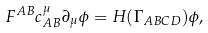Convert formula to latex. <formula><loc_0><loc_0><loc_500><loc_500>F ^ { A B } c ^ { \mu } _ { A B } \partial _ { \mu } \phi = H ( \Gamma _ { A B C D } ) \phi ,</formula> 